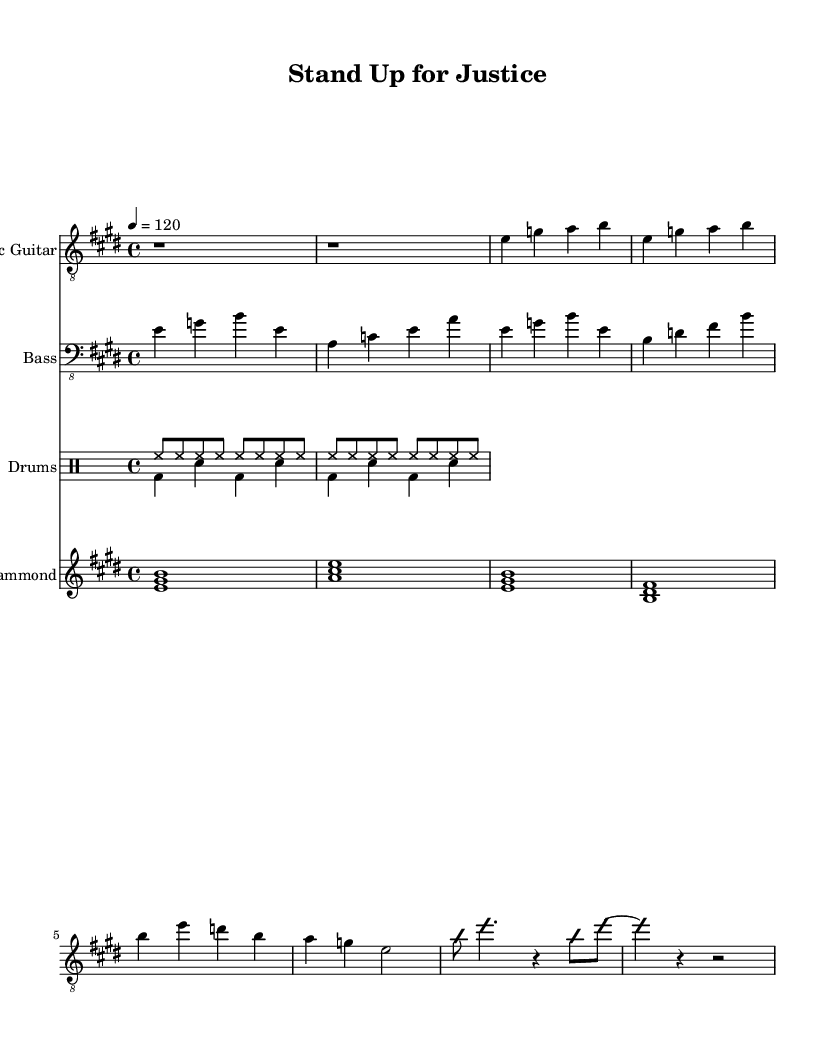What is the key signature of this music? The key signature can be determined by looking at the beginning of the music sheet. Here, the music is in E major, which has four sharps (F#, C#, G#, D#), indicated by the notation.
Answer: E major What is the time signature of this piece? The time signature is found at the start of the music, showing how many beats are in each measure. Here, it shows 4/4, meaning there are four beats in a measure, and the quarter note gets one beat.
Answer: 4/4 What is the tempo marking for this composition? The tempo is indicated by the numerical marking placed at the beginning of the piece. It states that the piece should be played at 120 beats per minute, a common tempo for electric blues.
Answer: 120 What instrument is performing the melody? The melody is typically played by the highest staff in the sheet music, which, in this case, is designated as "Electric Guitar." This guitar part includes the main melodic line as well as improvisational sections.
Answer: Electric Guitar How many measures are in the first verse? To find the number of measures, we can look at the section labeled "Verse 1" in the sheet music. Counting the distinct grouped notes or rests, there are a total of 4 measures in this section.
Answer: 4 What are the lyrical themes expressed in the song? The lyrics provide insights into the themes of justice and activism, as seen in lines that talk about "voices rise" and "fighting for justice." These phrases reflect a clear advocacy for human rights and activism.
Answer: Activism What type of music is this sheet music an example of? The style of the music is identified by both the genre indicated in the question and the characteristics of the composition, which incorporates elements like bluesy guitar lines and emphasis on social themes. Thus, this is categorized as Electric Blues.
Answer: Electric Blues 